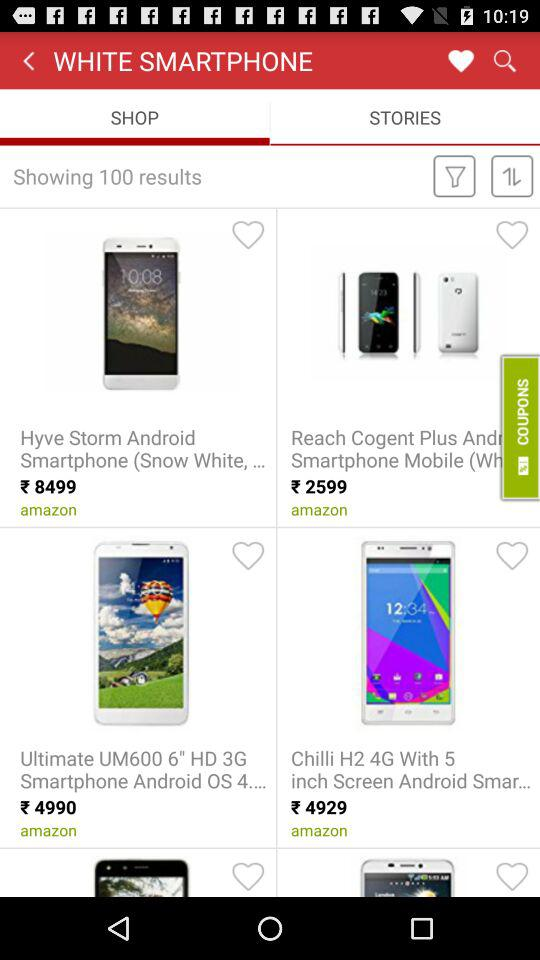Which option is selected for white smartphone? The selected option is "SHOP". 